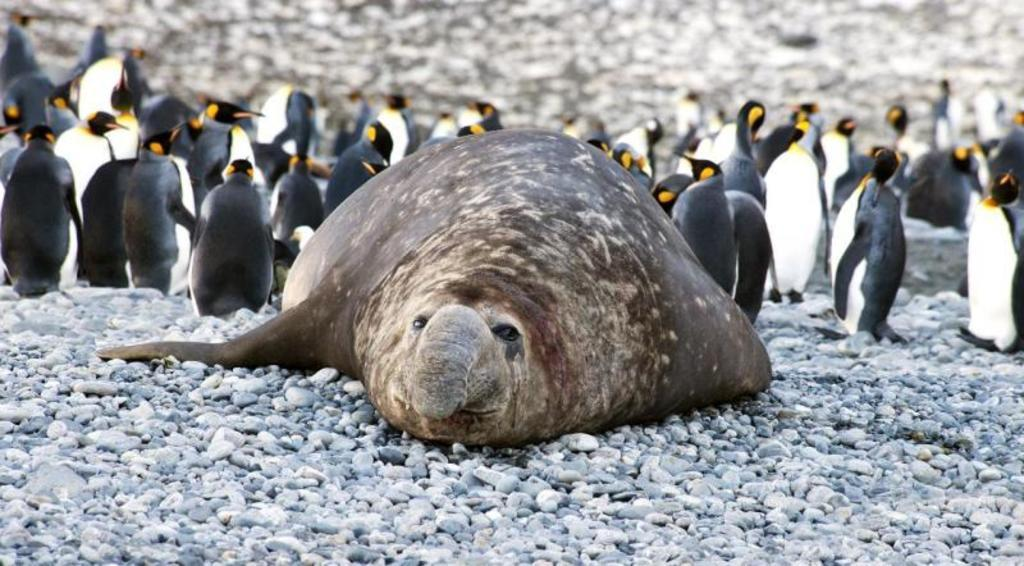What animal is in the foreground of the image? There is an elephant seal in the foreground of the image. What is the elephant seal resting on? The elephant seal is on stones. What other animals can be seen in the image? There are penguins in the background of the image. What type of letter is the elephant seal holding in the image? There is no letter present in the image; the elephant seal is resting on stones and is not holding anything. 